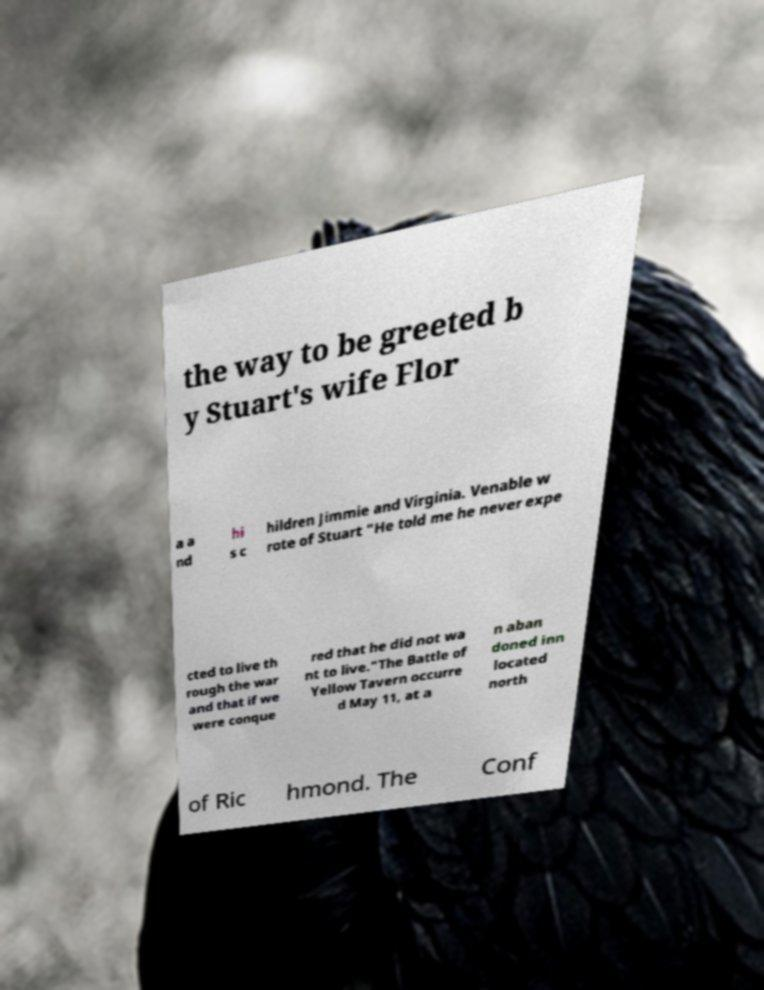I need the written content from this picture converted into text. Can you do that? the way to be greeted b y Stuart's wife Flor a a nd hi s c hildren Jimmie and Virginia. Venable w rote of Stuart "He told me he never expe cted to live th rough the war and that if we were conque red that he did not wa nt to live."The Battle of Yellow Tavern occurre d May 11, at a n aban doned inn located north of Ric hmond. The Conf 